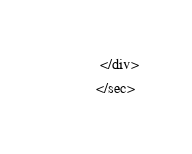Convert code to text. <code><loc_0><loc_0><loc_500><loc_500><_XML_> </div>
</sec>
</code> 